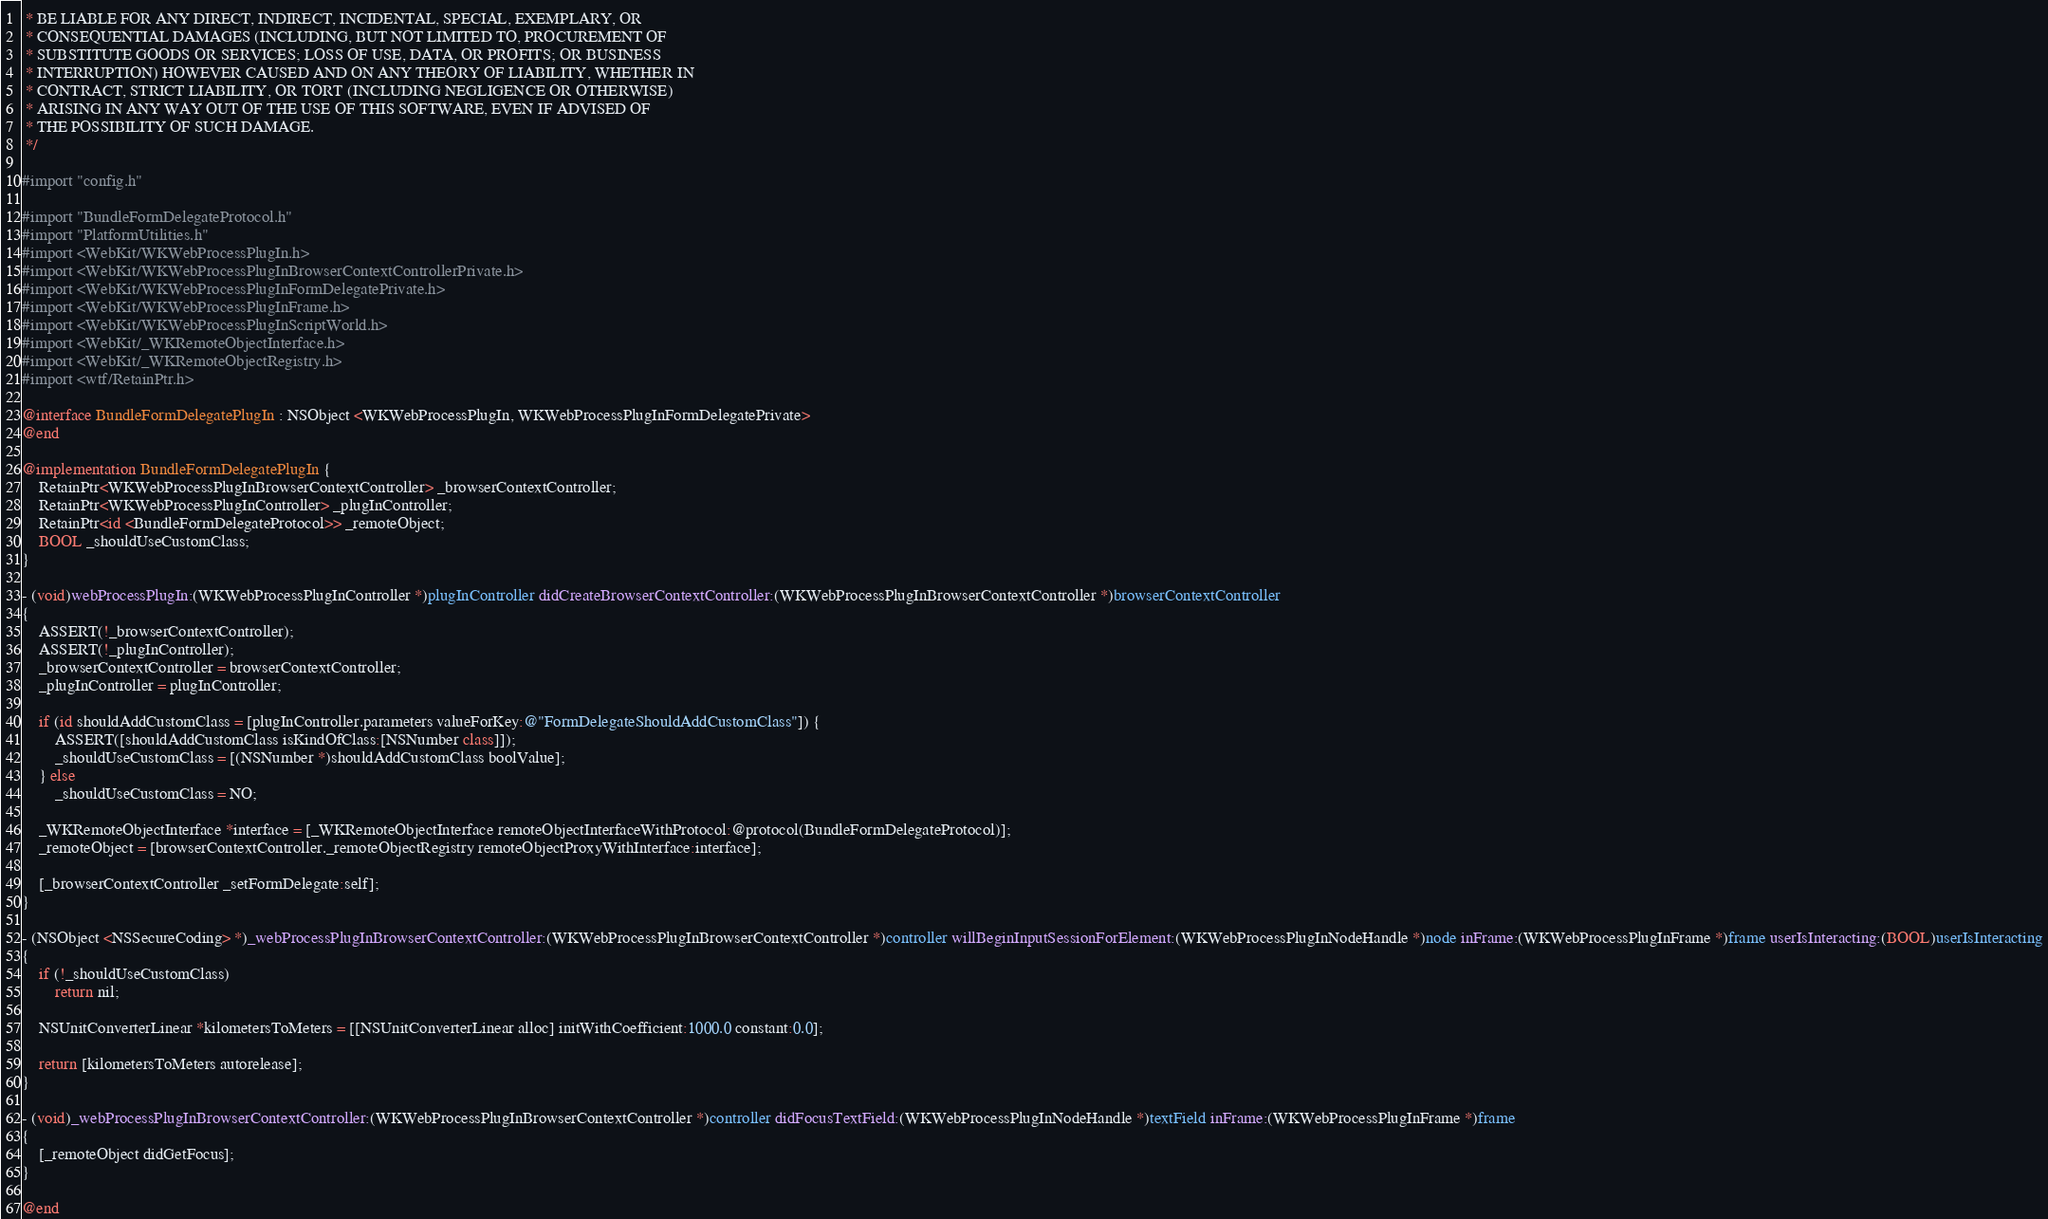<code> <loc_0><loc_0><loc_500><loc_500><_ObjectiveC_> * BE LIABLE FOR ANY DIRECT, INDIRECT, INCIDENTAL, SPECIAL, EXEMPLARY, OR
 * CONSEQUENTIAL DAMAGES (INCLUDING, BUT NOT LIMITED TO, PROCUREMENT OF
 * SUBSTITUTE GOODS OR SERVICES; LOSS OF USE, DATA, OR PROFITS; OR BUSINESS
 * INTERRUPTION) HOWEVER CAUSED AND ON ANY THEORY OF LIABILITY, WHETHER IN
 * CONTRACT, STRICT LIABILITY, OR TORT (INCLUDING NEGLIGENCE OR OTHERWISE)
 * ARISING IN ANY WAY OUT OF THE USE OF THIS SOFTWARE, EVEN IF ADVISED OF
 * THE POSSIBILITY OF SUCH DAMAGE.
 */

#import "config.h"

#import "BundleFormDelegateProtocol.h"
#import "PlatformUtilities.h"
#import <WebKit/WKWebProcessPlugIn.h>
#import <WebKit/WKWebProcessPlugInBrowserContextControllerPrivate.h>
#import <WebKit/WKWebProcessPlugInFormDelegatePrivate.h>
#import <WebKit/WKWebProcessPlugInFrame.h>
#import <WebKit/WKWebProcessPlugInScriptWorld.h>
#import <WebKit/_WKRemoteObjectInterface.h>
#import <WebKit/_WKRemoteObjectRegistry.h>
#import <wtf/RetainPtr.h>

@interface BundleFormDelegatePlugIn : NSObject <WKWebProcessPlugIn, WKWebProcessPlugInFormDelegatePrivate>
@end

@implementation BundleFormDelegatePlugIn {
    RetainPtr<WKWebProcessPlugInBrowserContextController> _browserContextController;
    RetainPtr<WKWebProcessPlugInController> _plugInController;
    RetainPtr<id <BundleFormDelegateProtocol>> _remoteObject;
    BOOL _shouldUseCustomClass;
}

- (void)webProcessPlugIn:(WKWebProcessPlugInController *)plugInController didCreateBrowserContextController:(WKWebProcessPlugInBrowserContextController *)browserContextController
{
    ASSERT(!_browserContextController);
    ASSERT(!_plugInController);
    _browserContextController = browserContextController;
    _plugInController = plugInController;

    if (id shouldAddCustomClass = [plugInController.parameters valueForKey:@"FormDelegateShouldAddCustomClass"]) {
        ASSERT([shouldAddCustomClass isKindOfClass:[NSNumber class]]);
        _shouldUseCustomClass = [(NSNumber *)shouldAddCustomClass boolValue];
    } else
        _shouldUseCustomClass = NO;

    _WKRemoteObjectInterface *interface = [_WKRemoteObjectInterface remoteObjectInterfaceWithProtocol:@protocol(BundleFormDelegateProtocol)];
    _remoteObject = [browserContextController._remoteObjectRegistry remoteObjectProxyWithInterface:interface];

    [_browserContextController _setFormDelegate:self];
}

- (NSObject <NSSecureCoding> *)_webProcessPlugInBrowserContextController:(WKWebProcessPlugInBrowserContextController *)controller willBeginInputSessionForElement:(WKWebProcessPlugInNodeHandle *)node inFrame:(WKWebProcessPlugInFrame *)frame userIsInteracting:(BOOL)userIsInteracting
{
    if (!_shouldUseCustomClass)
        return nil;

    NSUnitConverterLinear *kilometersToMeters = [[NSUnitConverterLinear alloc] initWithCoefficient:1000.0 constant:0.0];

    return [kilometersToMeters autorelease];
}

- (void)_webProcessPlugInBrowserContextController:(WKWebProcessPlugInBrowserContextController *)controller didFocusTextField:(WKWebProcessPlugInNodeHandle *)textField inFrame:(WKWebProcessPlugInFrame *)frame
{
    [_remoteObject didGetFocus];
}

@end
</code> 